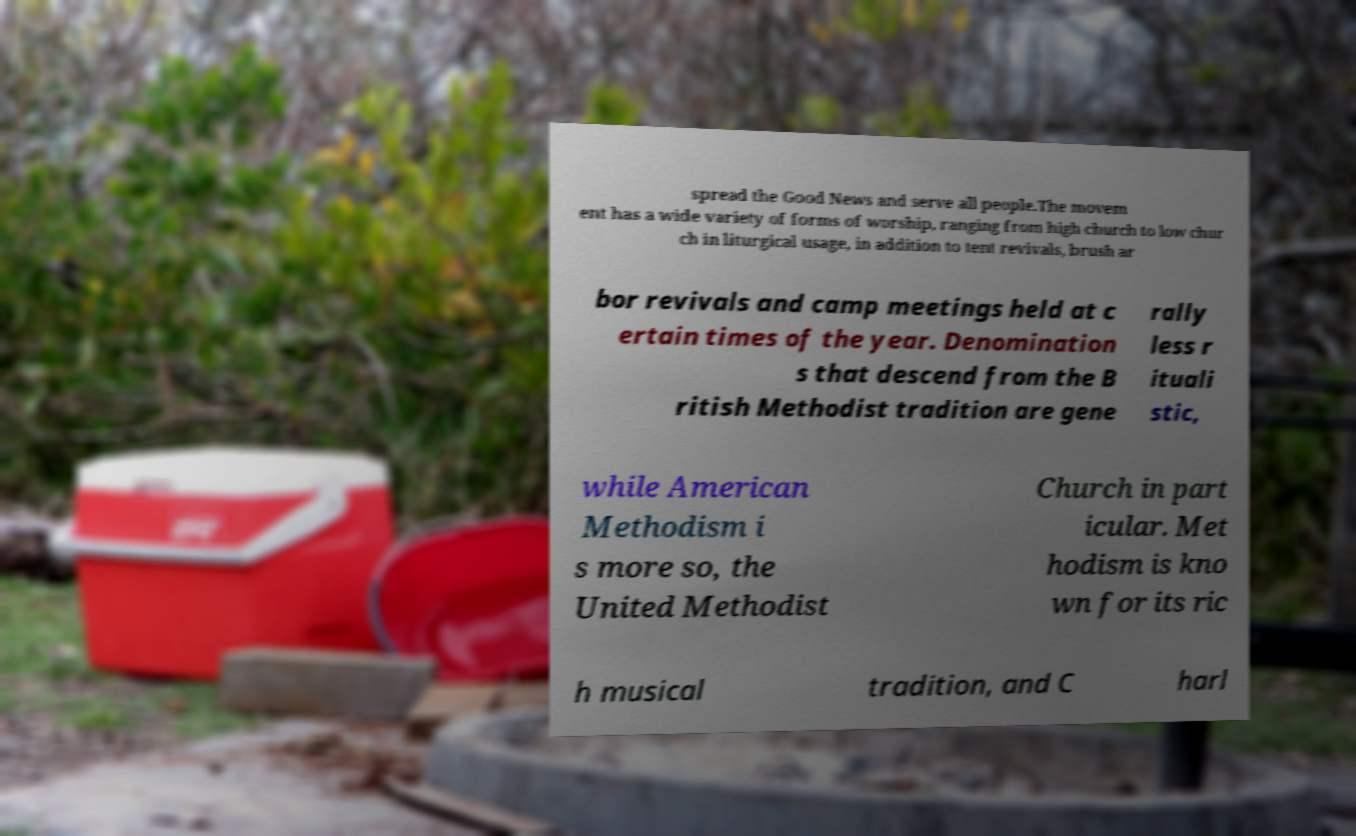Can you accurately transcribe the text from the provided image for me? spread the Good News and serve all people.The movem ent has a wide variety of forms of worship, ranging from high church to low chur ch in liturgical usage, in addition to tent revivals, brush ar bor revivals and camp meetings held at c ertain times of the year. Denomination s that descend from the B ritish Methodist tradition are gene rally less r ituali stic, while American Methodism i s more so, the United Methodist Church in part icular. Met hodism is kno wn for its ric h musical tradition, and C harl 